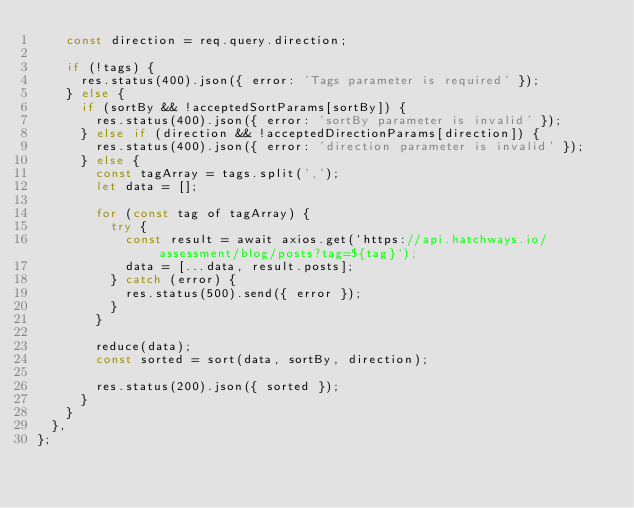<code> <loc_0><loc_0><loc_500><loc_500><_JavaScript_>    const direction = req.query.direction;

    if (!tags) {
      res.status(400).json({ error: 'Tags parameter is required' });
    } else {
      if (sortBy && !acceptedSortParams[sortBy]) {
        res.status(400).json({ error: 'sortBy parameter is invalid' });
      } else if (direction && !acceptedDirectionParams[direction]) {
        res.status(400).json({ error: 'direction parameter is invalid' });
      } else {
        const tagArray = tags.split(',');
        let data = [];

        for (const tag of tagArray) {
          try {
            const result = await axios.get(`https://api.hatchways.io/assessment/blog/posts?tag=${tag}`);
            data = [...data, result.posts];
          } catch (error) {
            res.status(500).send({ error });
          }
        }

        reduce(data);
        const sorted = sort(data, sortBy, direction);

        res.status(200).json({ sorted });
      }
    }
  },
};
</code> 